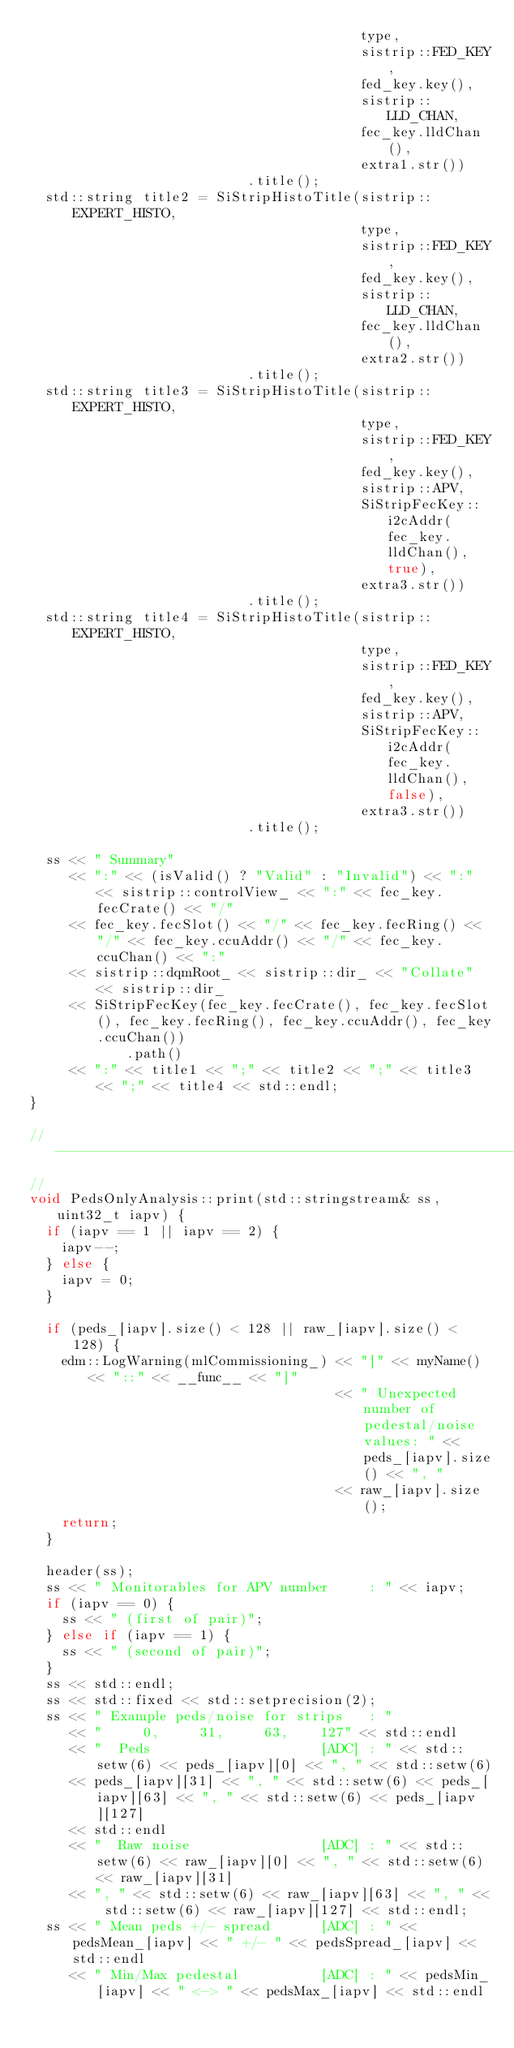<code> <loc_0><loc_0><loc_500><loc_500><_C++_>                                         type,
                                         sistrip::FED_KEY,
                                         fed_key.key(),
                                         sistrip::LLD_CHAN,
                                         fec_key.lldChan(),
                                         extra1.str())
                           .title();
  std::string title2 = SiStripHistoTitle(sistrip::EXPERT_HISTO,
                                         type,
                                         sistrip::FED_KEY,
                                         fed_key.key(),
                                         sistrip::LLD_CHAN,
                                         fec_key.lldChan(),
                                         extra2.str())
                           .title();
  std::string title3 = SiStripHistoTitle(sistrip::EXPERT_HISTO,
                                         type,
                                         sistrip::FED_KEY,
                                         fed_key.key(),
                                         sistrip::APV,
                                         SiStripFecKey::i2cAddr(fec_key.lldChan(), true),
                                         extra3.str())
                           .title();
  std::string title4 = SiStripHistoTitle(sistrip::EXPERT_HISTO,
                                         type,
                                         sistrip::FED_KEY,
                                         fed_key.key(),
                                         sistrip::APV,
                                         SiStripFecKey::i2cAddr(fec_key.lldChan(), false),
                                         extra3.str())
                           .title();

  ss << " Summary"
     << ":" << (isValid() ? "Valid" : "Invalid") << ":" << sistrip::controlView_ << ":" << fec_key.fecCrate() << "/"
     << fec_key.fecSlot() << "/" << fec_key.fecRing() << "/" << fec_key.ccuAddr() << "/" << fec_key.ccuChan() << ":"
     << sistrip::dqmRoot_ << sistrip::dir_ << "Collate" << sistrip::dir_
     << SiStripFecKey(fec_key.fecCrate(), fec_key.fecSlot(), fec_key.fecRing(), fec_key.ccuAddr(), fec_key.ccuChan())
            .path()
     << ":" << title1 << ";" << title2 << ";" << title3 << ";" << title4 << std::endl;
}

// ----------------------------------------------------------------------------
//
void PedsOnlyAnalysis::print(std::stringstream& ss, uint32_t iapv) {
  if (iapv == 1 || iapv == 2) {
    iapv--;
  } else {
    iapv = 0;
  }

  if (peds_[iapv].size() < 128 || raw_[iapv].size() < 128) {
    edm::LogWarning(mlCommissioning_) << "[" << myName() << "::" << __func__ << "]"
                                      << " Unexpected number of pedestal/noise values: " << peds_[iapv].size() << ", "
                                      << raw_[iapv].size();
    return;
  }

  header(ss);
  ss << " Monitorables for APV number     : " << iapv;
  if (iapv == 0) {
    ss << " (first of pair)";
  } else if (iapv == 1) {
    ss << " (second of pair)";
  }
  ss << std::endl;
  ss << std::fixed << std::setprecision(2);
  ss << " Example peds/noise for strips   : "
     << "     0,     31,     63,    127" << std::endl
     << "  Peds                     [ADC] : " << std::setw(6) << peds_[iapv][0] << ", " << std::setw(6)
     << peds_[iapv][31] << ", " << std::setw(6) << peds_[iapv][63] << ", " << std::setw(6) << peds_[iapv][127]
     << std::endl
     << "  Raw noise                [ADC] : " << std::setw(6) << raw_[iapv][0] << ", " << std::setw(6) << raw_[iapv][31]
     << ", " << std::setw(6) << raw_[iapv][63] << ", " << std::setw(6) << raw_[iapv][127] << std::endl;
  ss << " Mean peds +/- spread      [ADC] : " << pedsMean_[iapv] << " +/- " << pedsSpread_[iapv] << std::endl
     << " Min/Max pedestal          [ADC] : " << pedsMin_[iapv] << " <-> " << pedsMax_[iapv] << std::endl</code> 